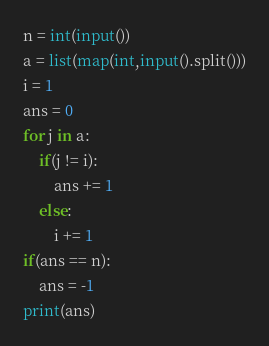Convert code to text. <code><loc_0><loc_0><loc_500><loc_500><_Python_>n = int(input())
a = list(map(int,input().split()))
i = 1
ans = 0
for j in a:
    if(j != i):
        ans += 1
    else:
        i += 1
if(ans == n):
    ans = -1
print(ans)</code> 